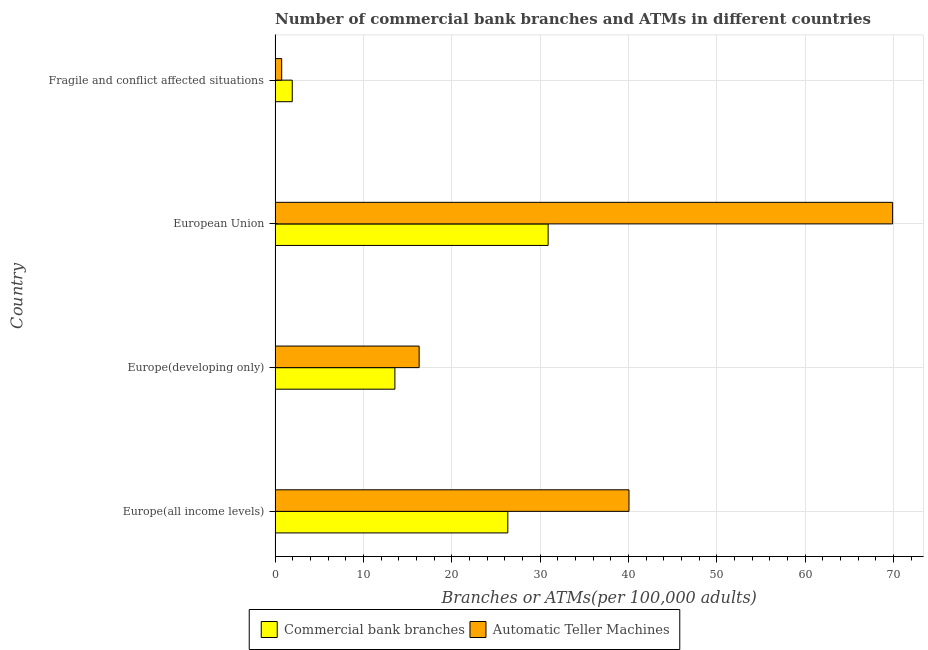How many groups of bars are there?
Give a very brief answer. 4. Are the number of bars per tick equal to the number of legend labels?
Make the answer very short. Yes. How many bars are there on the 1st tick from the top?
Make the answer very short. 2. What is the label of the 1st group of bars from the top?
Offer a terse response. Fragile and conflict affected situations. What is the number of atms in European Union?
Provide a succinct answer. 69.89. Across all countries, what is the maximum number of commercal bank branches?
Provide a short and direct response. 30.9. Across all countries, what is the minimum number of atms?
Offer a terse response. 0.75. In which country was the number of commercal bank branches minimum?
Make the answer very short. Fragile and conflict affected situations. What is the total number of commercal bank branches in the graph?
Ensure brevity in your answer.  72.75. What is the difference between the number of atms in Europe(all income levels) and that in Europe(developing only)?
Offer a very short reply. 23.75. What is the difference between the number of commercal bank branches in Europe(developing only) and the number of atms in Fragile and conflict affected situations?
Your response must be concise. 12.81. What is the average number of commercal bank branches per country?
Your response must be concise. 18.19. What is the difference between the number of commercal bank branches and number of atms in Fragile and conflict affected situations?
Offer a terse response. 1.2. What is the ratio of the number of atms in European Union to that in Fragile and conflict affected situations?
Keep it short and to the point. 93.49. Is the number of commercal bank branches in Europe(all income levels) less than that in European Union?
Provide a succinct answer. Yes. Is the difference between the number of atms in Europe(all income levels) and European Union greater than the difference between the number of commercal bank branches in Europe(all income levels) and European Union?
Provide a succinct answer. No. What is the difference between the highest and the second highest number of commercal bank branches?
Offer a terse response. 4.56. What is the difference between the highest and the lowest number of commercal bank branches?
Keep it short and to the point. 28.96. In how many countries, is the number of commercal bank branches greater than the average number of commercal bank branches taken over all countries?
Ensure brevity in your answer.  2. Is the sum of the number of atms in European Union and Fragile and conflict affected situations greater than the maximum number of commercal bank branches across all countries?
Offer a terse response. Yes. What does the 1st bar from the top in Europe(all income levels) represents?
Provide a succinct answer. Automatic Teller Machines. What does the 2nd bar from the bottom in Europe(developing only) represents?
Make the answer very short. Automatic Teller Machines. Are all the bars in the graph horizontal?
Your answer should be compact. Yes. How many countries are there in the graph?
Offer a terse response. 4. What is the difference between two consecutive major ticks on the X-axis?
Offer a very short reply. 10. Are the values on the major ticks of X-axis written in scientific E-notation?
Offer a terse response. No. Does the graph contain any zero values?
Give a very brief answer. No. Does the graph contain grids?
Your answer should be very brief. Yes. Where does the legend appear in the graph?
Offer a very short reply. Bottom center. How many legend labels are there?
Give a very brief answer. 2. What is the title of the graph?
Provide a succinct answer. Number of commercial bank branches and ATMs in different countries. What is the label or title of the X-axis?
Offer a very short reply. Branches or ATMs(per 100,0 adults). What is the Branches or ATMs(per 100,000 adults) of Commercial bank branches in Europe(all income levels)?
Offer a terse response. 26.34. What is the Branches or ATMs(per 100,000 adults) in Automatic Teller Machines in Europe(all income levels)?
Keep it short and to the point. 40.06. What is the Branches or ATMs(per 100,000 adults) in Commercial bank branches in Europe(developing only)?
Provide a short and direct response. 13.56. What is the Branches or ATMs(per 100,000 adults) of Automatic Teller Machines in Europe(developing only)?
Make the answer very short. 16.3. What is the Branches or ATMs(per 100,000 adults) in Commercial bank branches in European Union?
Keep it short and to the point. 30.9. What is the Branches or ATMs(per 100,000 adults) of Automatic Teller Machines in European Union?
Your answer should be compact. 69.89. What is the Branches or ATMs(per 100,000 adults) of Commercial bank branches in Fragile and conflict affected situations?
Your response must be concise. 1.94. What is the Branches or ATMs(per 100,000 adults) of Automatic Teller Machines in Fragile and conflict affected situations?
Keep it short and to the point. 0.75. Across all countries, what is the maximum Branches or ATMs(per 100,000 adults) of Commercial bank branches?
Provide a short and direct response. 30.9. Across all countries, what is the maximum Branches or ATMs(per 100,000 adults) of Automatic Teller Machines?
Provide a succinct answer. 69.89. Across all countries, what is the minimum Branches or ATMs(per 100,000 adults) of Commercial bank branches?
Offer a terse response. 1.94. Across all countries, what is the minimum Branches or ATMs(per 100,000 adults) in Automatic Teller Machines?
Your answer should be compact. 0.75. What is the total Branches or ATMs(per 100,000 adults) in Commercial bank branches in the graph?
Give a very brief answer. 72.75. What is the total Branches or ATMs(per 100,000 adults) of Automatic Teller Machines in the graph?
Your answer should be very brief. 127. What is the difference between the Branches or ATMs(per 100,000 adults) of Commercial bank branches in Europe(all income levels) and that in Europe(developing only)?
Your response must be concise. 12.78. What is the difference between the Branches or ATMs(per 100,000 adults) in Automatic Teller Machines in Europe(all income levels) and that in Europe(developing only)?
Provide a short and direct response. 23.75. What is the difference between the Branches or ATMs(per 100,000 adults) of Commercial bank branches in Europe(all income levels) and that in European Union?
Your response must be concise. -4.56. What is the difference between the Branches or ATMs(per 100,000 adults) of Automatic Teller Machines in Europe(all income levels) and that in European Union?
Your answer should be compact. -29.84. What is the difference between the Branches or ATMs(per 100,000 adults) of Commercial bank branches in Europe(all income levels) and that in Fragile and conflict affected situations?
Ensure brevity in your answer.  24.4. What is the difference between the Branches or ATMs(per 100,000 adults) in Automatic Teller Machines in Europe(all income levels) and that in Fragile and conflict affected situations?
Give a very brief answer. 39.31. What is the difference between the Branches or ATMs(per 100,000 adults) of Commercial bank branches in Europe(developing only) and that in European Union?
Provide a succinct answer. -17.34. What is the difference between the Branches or ATMs(per 100,000 adults) in Automatic Teller Machines in Europe(developing only) and that in European Union?
Ensure brevity in your answer.  -53.59. What is the difference between the Branches or ATMs(per 100,000 adults) in Commercial bank branches in Europe(developing only) and that in Fragile and conflict affected situations?
Provide a succinct answer. 11.62. What is the difference between the Branches or ATMs(per 100,000 adults) of Automatic Teller Machines in Europe(developing only) and that in Fragile and conflict affected situations?
Provide a short and direct response. 15.56. What is the difference between the Branches or ATMs(per 100,000 adults) in Commercial bank branches in European Union and that in Fragile and conflict affected situations?
Ensure brevity in your answer.  28.96. What is the difference between the Branches or ATMs(per 100,000 adults) in Automatic Teller Machines in European Union and that in Fragile and conflict affected situations?
Your answer should be very brief. 69.15. What is the difference between the Branches or ATMs(per 100,000 adults) of Commercial bank branches in Europe(all income levels) and the Branches or ATMs(per 100,000 adults) of Automatic Teller Machines in Europe(developing only)?
Your answer should be very brief. 10.04. What is the difference between the Branches or ATMs(per 100,000 adults) in Commercial bank branches in Europe(all income levels) and the Branches or ATMs(per 100,000 adults) in Automatic Teller Machines in European Union?
Offer a terse response. -43.55. What is the difference between the Branches or ATMs(per 100,000 adults) in Commercial bank branches in Europe(all income levels) and the Branches or ATMs(per 100,000 adults) in Automatic Teller Machines in Fragile and conflict affected situations?
Your answer should be very brief. 25.59. What is the difference between the Branches or ATMs(per 100,000 adults) of Commercial bank branches in Europe(developing only) and the Branches or ATMs(per 100,000 adults) of Automatic Teller Machines in European Union?
Ensure brevity in your answer.  -56.33. What is the difference between the Branches or ATMs(per 100,000 adults) in Commercial bank branches in Europe(developing only) and the Branches or ATMs(per 100,000 adults) in Automatic Teller Machines in Fragile and conflict affected situations?
Offer a terse response. 12.81. What is the difference between the Branches or ATMs(per 100,000 adults) in Commercial bank branches in European Union and the Branches or ATMs(per 100,000 adults) in Automatic Teller Machines in Fragile and conflict affected situations?
Make the answer very short. 30.16. What is the average Branches or ATMs(per 100,000 adults) of Commercial bank branches per country?
Offer a terse response. 18.19. What is the average Branches or ATMs(per 100,000 adults) of Automatic Teller Machines per country?
Provide a short and direct response. 31.75. What is the difference between the Branches or ATMs(per 100,000 adults) of Commercial bank branches and Branches or ATMs(per 100,000 adults) of Automatic Teller Machines in Europe(all income levels)?
Your answer should be compact. -13.71. What is the difference between the Branches or ATMs(per 100,000 adults) of Commercial bank branches and Branches or ATMs(per 100,000 adults) of Automatic Teller Machines in Europe(developing only)?
Ensure brevity in your answer.  -2.74. What is the difference between the Branches or ATMs(per 100,000 adults) of Commercial bank branches and Branches or ATMs(per 100,000 adults) of Automatic Teller Machines in European Union?
Offer a very short reply. -38.99. What is the difference between the Branches or ATMs(per 100,000 adults) of Commercial bank branches and Branches or ATMs(per 100,000 adults) of Automatic Teller Machines in Fragile and conflict affected situations?
Offer a very short reply. 1.2. What is the ratio of the Branches or ATMs(per 100,000 adults) in Commercial bank branches in Europe(all income levels) to that in Europe(developing only)?
Your answer should be compact. 1.94. What is the ratio of the Branches or ATMs(per 100,000 adults) of Automatic Teller Machines in Europe(all income levels) to that in Europe(developing only)?
Your answer should be very brief. 2.46. What is the ratio of the Branches or ATMs(per 100,000 adults) in Commercial bank branches in Europe(all income levels) to that in European Union?
Offer a terse response. 0.85. What is the ratio of the Branches or ATMs(per 100,000 adults) of Automatic Teller Machines in Europe(all income levels) to that in European Union?
Your answer should be compact. 0.57. What is the ratio of the Branches or ATMs(per 100,000 adults) of Commercial bank branches in Europe(all income levels) to that in Fragile and conflict affected situations?
Your answer should be very brief. 13.56. What is the ratio of the Branches or ATMs(per 100,000 adults) in Automatic Teller Machines in Europe(all income levels) to that in Fragile and conflict affected situations?
Offer a very short reply. 53.58. What is the ratio of the Branches or ATMs(per 100,000 adults) of Commercial bank branches in Europe(developing only) to that in European Union?
Make the answer very short. 0.44. What is the ratio of the Branches or ATMs(per 100,000 adults) of Automatic Teller Machines in Europe(developing only) to that in European Union?
Make the answer very short. 0.23. What is the ratio of the Branches or ATMs(per 100,000 adults) of Commercial bank branches in Europe(developing only) to that in Fragile and conflict affected situations?
Provide a succinct answer. 6.98. What is the ratio of the Branches or ATMs(per 100,000 adults) in Automatic Teller Machines in Europe(developing only) to that in Fragile and conflict affected situations?
Provide a succinct answer. 21.81. What is the ratio of the Branches or ATMs(per 100,000 adults) of Commercial bank branches in European Union to that in Fragile and conflict affected situations?
Your answer should be compact. 15.91. What is the ratio of the Branches or ATMs(per 100,000 adults) of Automatic Teller Machines in European Union to that in Fragile and conflict affected situations?
Offer a terse response. 93.49. What is the difference between the highest and the second highest Branches or ATMs(per 100,000 adults) of Commercial bank branches?
Keep it short and to the point. 4.56. What is the difference between the highest and the second highest Branches or ATMs(per 100,000 adults) in Automatic Teller Machines?
Provide a succinct answer. 29.84. What is the difference between the highest and the lowest Branches or ATMs(per 100,000 adults) in Commercial bank branches?
Provide a succinct answer. 28.96. What is the difference between the highest and the lowest Branches or ATMs(per 100,000 adults) in Automatic Teller Machines?
Make the answer very short. 69.15. 